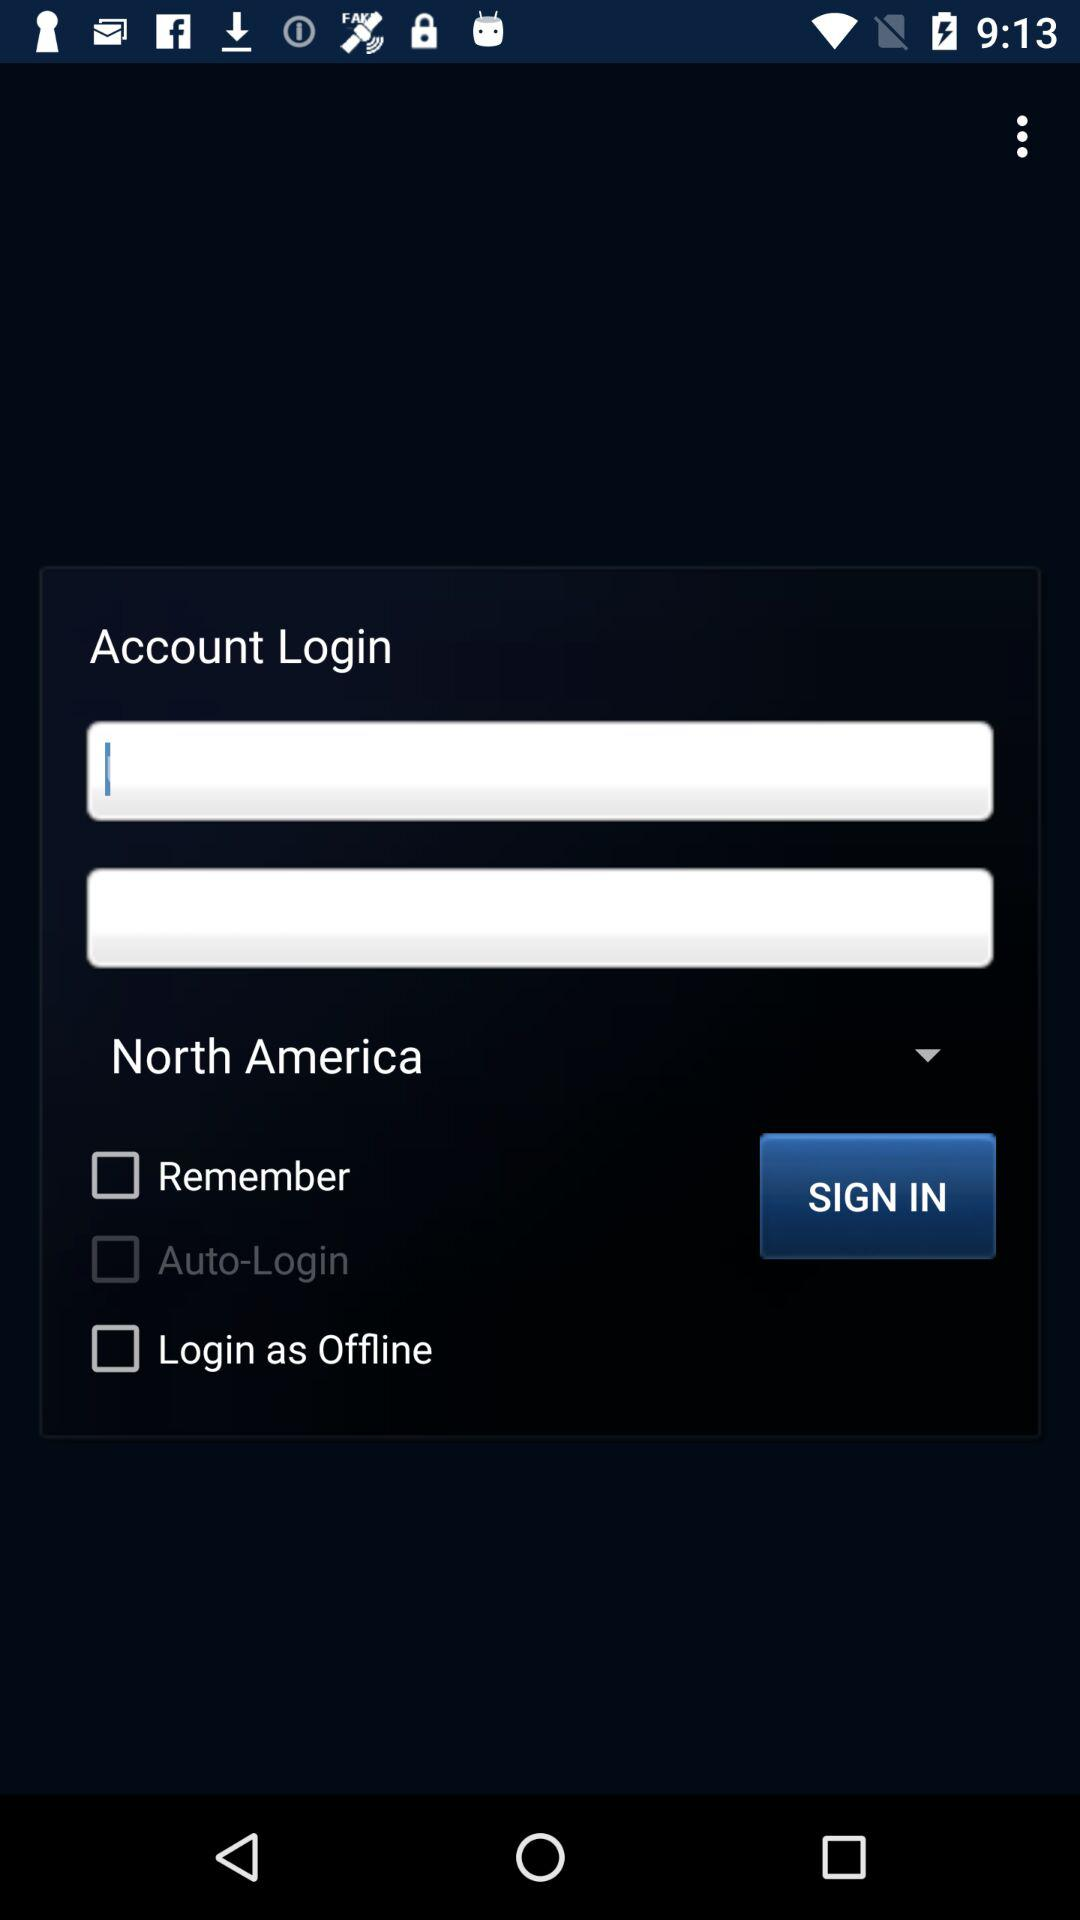What are the requirements for the password?
When the provided information is insufficient, respond with <no answer>. <no answer> 